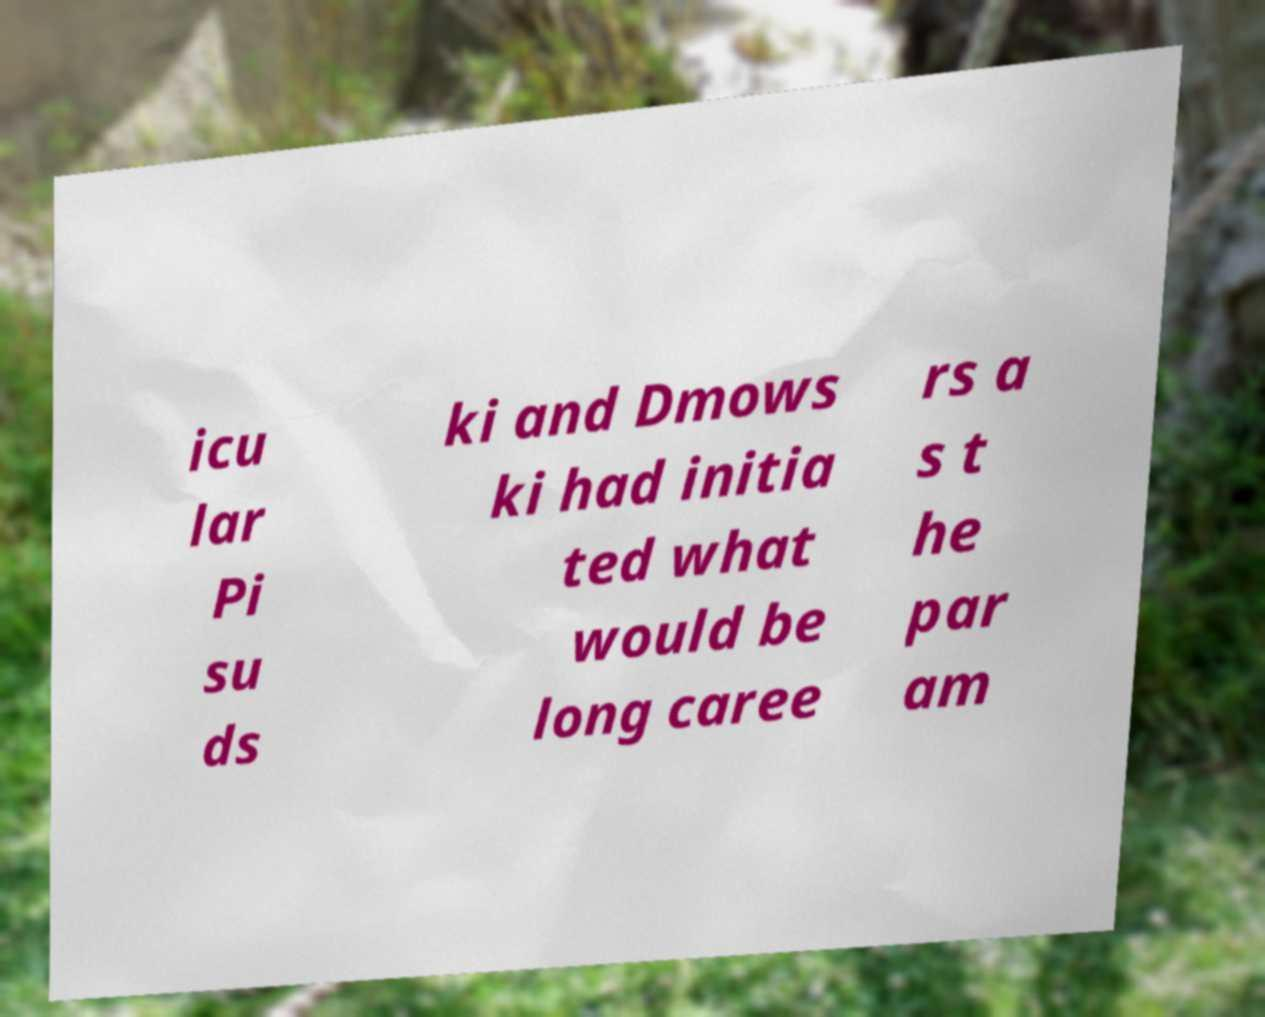Can you read and provide the text displayed in the image?This photo seems to have some interesting text. Can you extract and type it out for me? icu lar Pi su ds ki and Dmows ki had initia ted what would be long caree rs a s t he par am 